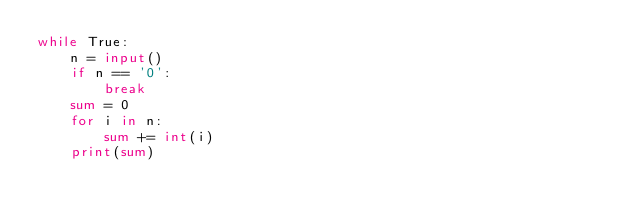Convert code to text. <code><loc_0><loc_0><loc_500><loc_500><_Python_>while True:
    n = input()
    if n == '0':
        break
    sum = 0
    for i in n:
        sum += int(i)
    print(sum)</code> 